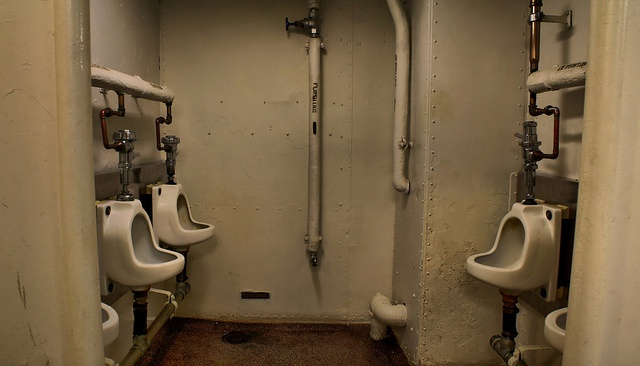Describe the objects in this image and their specific colors. I can see toilet in olive, gray, tan, and black tones, toilet in olive, gray, and tan tones, toilet in olive, gray, tan, and black tones, toilet in olive, gray, black, and tan tones, and toilet in olive, gray, black, and tan tones in this image. 